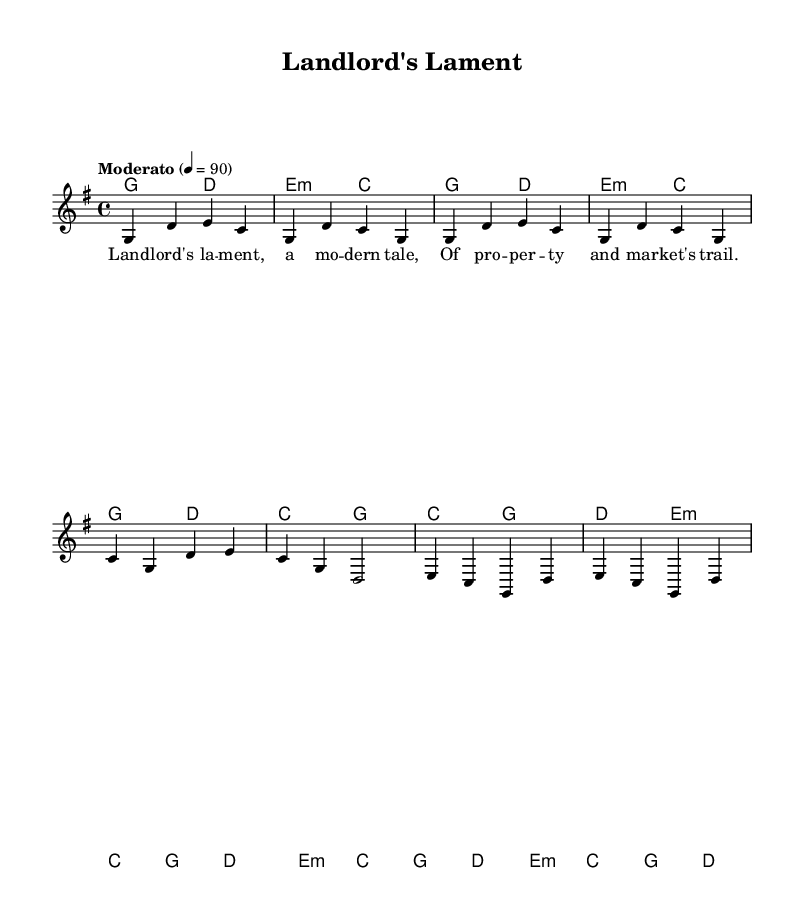What is the key signature of this music? The key signature appears at the beginning of the staff. In this case, we see one sharp (F#), which indicates that the key signature is G major.
Answer: G major What is the time signature of this music? The time signature is located after the key signature at the beginning of the piece. Here it shows 4/4, meaning there are four beats in each measure, and a quarter note receives one beat.
Answer: 4/4 What is the tempo marking? The tempo marking is expressed at the start of the score. It states "Moderato" with a metronome marked at 90 beats per minute, indicating a moderately paced tempo.
Answer: Moderato, 90 What chords are used in the intro? The intro section lists the chords in the harmony part. Specifically, it comprises a G major chord followed by a D major chord, and then an E minor chord and a C major chord.
Answer: G, D, E minor, C How many measures are in the chorus? To determine the measures in the chorus, we refer to the section labeled as the chorus in the harmony part. The chorus consists of four measures displayed above the corresponding melody.
Answer: 4 What narrative theme is this piece focused on? The lyrics in this music primarily reflect a narrative regarding property and market challenges, as indicated by the title "Landlord's Lament" and the first line of the verse.
Answer: Property management What type of musical form does this piece represent? The structure of the piece includes an intro, verses, a chorus, and a bridge. This indicates that it follows a traditional folk song structure that incorporates storytelling elements.
Answer: Folk song form 